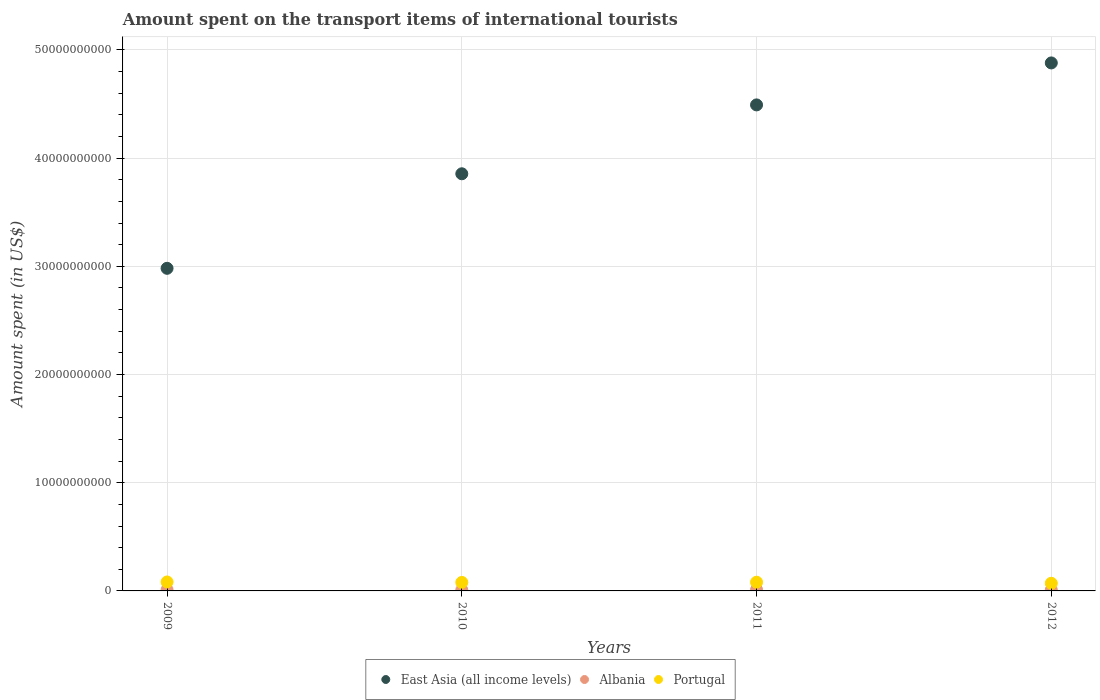How many different coloured dotlines are there?
Your answer should be very brief. 3. What is the amount spent on the transport items of international tourists in East Asia (all income levels) in 2010?
Provide a succinct answer. 3.86e+1. Across all years, what is the maximum amount spent on the transport items of international tourists in Albania?
Your response must be concise. 1.13e+08. Across all years, what is the minimum amount spent on the transport items of international tourists in Portugal?
Your answer should be compact. 7.06e+08. In which year was the amount spent on the transport items of international tourists in East Asia (all income levels) minimum?
Keep it short and to the point. 2009. What is the total amount spent on the transport items of international tourists in Portugal in the graph?
Keep it short and to the point. 3.12e+09. What is the difference between the amount spent on the transport items of international tourists in Albania in 2009 and that in 2012?
Your answer should be compact. 1.70e+07. What is the difference between the amount spent on the transport items of international tourists in Albania in 2012 and the amount spent on the transport items of international tourists in Portugal in 2010?
Keep it short and to the point. -6.96e+08. What is the average amount spent on the transport items of international tourists in Albania per year?
Provide a short and direct response. 1.00e+08. In the year 2010, what is the difference between the amount spent on the transport items of international tourists in Portugal and amount spent on the transport items of international tourists in Albania?
Ensure brevity in your answer.  6.94e+08. What is the ratio of the amount spent on the transport items of international tourists in Albania in 2010 to that in 2011?
Your response must be concise. 0.81. Is the amount spent on the transport items of international tourists in East Asia (all income levels) in 2010 less than that in 2011?
Keep it short and to the point. Yes. What is the difference between the highest and the second highest amount spent on the transport items of international tourists in East Asia (all income levels)?
Make the answer very short. 3.88e+09. What is the difference between the highest and the lowest amount spent on the transport items of international tourists in Portugal?
Offer a very short reply. 1.22e+08. Is the sum of the amount spent on the transport items of international tourists in Portugal in 2009 and 2012 greater than the maximum amount spent on the transport items of international tourists in East Asia (all income levels) across all years?
Keep it short and to the point. No. Does the amount spent on the transport items of international tourists in Albania monotonically increase over the years?
Give a very brief answer. No. Is the amount spent on the transport items of international tourists in Portugal strictly less than the amount spent on the transport items of international tourists in East Asia (all income levels) over the years?
Give a very brief answer. Yes. How many dotlines are there?
Make the answer very short. 3. How many years are there in the graph?
Provide a short and direct response. 4. Are the values on the major ticks of Y-axis written in scientific E-notation?
Your answer should be compact. No. Where does the legend appear in the graph?
Ensure brevity in your answer.  Bottom center. What is the title of the graph?
Offer a terse response. Amount spent on the transport items of international tourists. Does "South Africa" appear as one of the legend labels in the graph?
Offer a very short reply. No. What is the label or title of the Y-axis?
Your response must be concise. Amount spent (in US$). What is the Amount spent (in US$) of East Asia (all income levels) in 2009?
Your answer should be very brief. 2.98e+1. What is the Amount spent (in US$) of Albania in 2009?
Provide a short and direct response. 1.07e+08. What is the Amount spent (in US$) in Portugal in 2009?
Make the answer very short. 8.28e+08. What is the Amount spent (in US$) of East Asia (all income levels) in 2010?
Ensure brevity in your answer.  3.86e+1. What is the Amount spent (in US$) in Albania in 2010?
Offer a very short reply. 9.20e+07. What is the Amount spent (in US$) in Portugal in 2010?
Offer a very short reply. 7.86e+08. What is the Amount spent (in US$) of East Asia (all income levels) in 2011?
Give a very brief answer. 4.49e+1. What is the Amount spent (in US$) in Albania in 2011?
Offer a very short reply. 1.13e+08. What is the Amount spent (in US$) of Portugal in 2011?
Your answer should be compact. 8.05e+08. What is the Amount spent (in US$) of East Asia (all income levels) in 2012?
Ensure brevity in your answer.  4.88e+1. What is the Amount spent (in US$) in Albania in 2012?
Provide a short and direct response. 9.00e+07. What is the Amount spent (in US$) in Portugal in 2012?
Your answer should be compact. 7.06e+08. Across all years, what is the maximum Amount spent (in US$) of East Asia (all income levels)?
Your answer should be very brief. 4.88e+1. Across all years, what is the maximum Amount spent (in US$) of Albania?
Your answer should be compact. 1.13e+08. Across all years, what is the maximum Amount spent (in US$) of Portugal?
Make the answer very short. 8.28e+08. Across all years, what is the minimum Amount spent (in US$) of East Asia (all income levels)?
Offer a very short reply. 2.98e+1. Across all years, what is the minimum Amount spent (in US$) of Albania?
Ensure brevity in your answer.  9.00e+07. Across all years, what is the minimum Amount spent (in US$) of Portugal?
Keep it short and to the point. 7.06e+08. What is the total Amount spent (in US$) of East Asia (all income levels) in the graph?
Keep it short and to the point. 1.62e+11. What is the total Amount spent (in US$) in Albania in the graph?
Ensure brevity in your answer.  4.02e+08. What is the total Amount spent (in US$) in Portugal in the graph?
Provide a short and direct response. 3.12e+09. What is the difference between the Amount spent (in US$) in East Asia (all income levels) in 2009 and that in 2010?
Your response must be concise. -8.74e+09. What is the difference between the Amount spent (in US$) in Albania in 2009 and that in 2010?
Make the answer very short. 1.50e+07. What is the difference between the Amount spent (in US$) in Portugal in 2009 and that in 2010?
Make the answer very short. 4.20e+07. What is the difference between the Amount spent (in US$) of East Asia (all income levels) in 2009 and that in 2011?
Provide a succinct answer. -1.51e+1. What is the difference between the Amount spent (in US$) of Albania in 2009 and that in 2011?
Offer a terse response. -6.00e+06. What is the difference between the Amount spent (in US$) of Portugal in 2009 and that in 2011?
Provide a short and direct response. 2.30e+07. What is the difference between the Amount spent (in US$) in East Asia (all income levels) in 2009 and that in 2012?
Offer a very short reply. -1.90e+1. What is the difference between the Amount spent (in US$) of Albania in 2009 and that in 2012?
Your response must be concise. 1.70e+07. What is the difference between the Amount spent (in US$) of Portugal in 2009 and that in 2012?
Your answer should be very brief. 1.22e+08. What is the difference between the Amount spent (in US$) in East Asia (all income levels) in 2010 and that in 2011?
Give a very brief answer. -6.37e+09. What is the difference between the Amount spent (in US$) of Albania in 2010 and that in 2011?
Provide a short and direct response. -2.10e+07. What is the difference between the Amount spent (in US$) in Portugal in 2010 and that in 2011?
Make the answer very short. -1.90e+07. What is the difference between the Amount spent (in US$) of East Asia (all income levels) in 2010 and that in 2012?
Offer a terse response. -1.02e+1. What is the difference between the Amount spent (in US$) of Albania in 2010 and that in 2012?
Your answer should be compact. 2.00e+06. What is the difference between the Amount spent (in US$) in Portugal in 2010 and that in 2012?
Your answer should be compact. 8.00e+07. What is the difference between the Amount spent (in US$) of East Asia (all income levels) in 2011 and that in 2012?
Ensure brevity in your answer.  -3.88e+09. What is the difference between the Amount spent (in US$) in Albania in 2011 and that in 2012?
Keep it short and to the point. 2.30e+07. What is the difference between the Amount spent (in US$) in Portugal in 2011 and that in 2012?
Your answer should be compact. 9.90e+07. What is the difference between the Amount spent (in US$) of East Asia (all income levels) in 2009 and the Amount spent (in US$) of Albania in 2010?
Give a very brief answer. 2.97e+1. What is the difference between the Amount spent (in US$) in East Asia (all income levels) in 2009 and the Amount spent (in US$) in Portugal in 2010?
Your response must be concise. 2.90e+1. What is the difference between the Amount spent (in US$) of Albania in 2009 and the Amount spent (in US$) of Portugal in 2010?
Your answer should be very brief. -6.79e+08. What is the difference between the Amount spent (in US$) in East Asia (all income levels) in 2009 and the Amount spent (in US$) in Albania in 2011?
Offer a very short reply. 2.97e+1. What is the difference between the Amount spent (in US$) in East Asia (all income levels) in 2009 and the Amount spent (in US$) in Portugal in 2011?
Offer a terse response. 2.90e+1. What is the difference between the Amount spent (in US$) in Albania in 2009 and the Amount spent (in US$) in Portugal in 2011?
Provide a short and direct response. -6.98e+08. What is the difference between the Amount spent (in US$) of East Asia (all income levels) in 2009 and the Amount spent (in US$) of Albania in 2012?
Provide a succinct answer. 2.97e+1. What is the difference between the Amount spent (in US$) of East Asia (all income levels) in 2009 and the Amount spent (in US$) of Portugal in 2012?
Provide a succinct answer. 2.91e+1. What is the difference between the Amount spent (in US$) in Albania in 2009 and the Amount spent (in US$) in Portugal in 2012?
Give a very brief answer. -5.99e+08. What is the difference between the Amount spent (in US$) of East Asia (all income levels) in 2010 and the Amount spent (in US$) of Albania in 2011?
Keep it short and to the point. 3.84e+1. What is the difference between the Amount spent (in US$) in East Asia (all income levels) in 2010 and the Amount spent (in US$) in Portugal in 2011?
Your answer should be very brief. 3.78e+1. What is the difference between the Amount spent (in US$) in Albania in 2010 and the Amount spent (in US$) in Portugal in 2011?
Give a very brief answer. -7.13e+08. What is the difference between the Amount spent (in US$) in East Asia (all income levels) in 2010 and the Amount spent (in US$) in Albania in 2012?
Your answer should be very brief. 3.85e+1. What is the difference between the Amount spent (in US$) in East Asia (all income levels) in 2010 and the Amount spent (in US$) in Portugal in 2012?
Offer a terse response. 3.78e+1. What is the difference between the Amount spent (in US$) in Albania in 2010 and the Amount spent (in US$) in Portugal in 2012?
Your answer should be very brief. -6.14e+08. What is the difference between the Amount spent (in US$) of East Asia (all income levels) in 2011 and the Amount spent (in US$) of Albania in 2012?
Your answer should be compact. 4.48e+1. What is the difference between the Amount spent (in US$) in East Asia (all income levels) in 2011 and the Amount spent (in US$) in Portugal in 2012?
Make the answer very short. 4.42e+1. What is the difference between the Amount spent (in US$) in Albania in 2011 and the Amount spent (in US$) in Portugal in 2012?
Offer a terse response. -5.93e+08. What is the average Amount spent (in US$) of East Asia (all income levels) per year?
Your answer should be compact. 4.05e+1. What is the average Amount spent (in US$) in Albania per year?
Make the answer very short. 1.00e+08. What is the average Amount spent (in US$) of Portugal per year?
Offer a very short reply. 7.81e+08. In the year 2009, what is the difference between the Amount spent (in US$) in East Asia (all income levels) and Amount spent (in US$) in Albania?
Provide a succinct answer. 2.97e+1. In the year 2009, what is the difference between the Amount spent (in US$) in East Asia (all income levels) and Amount spent (in US$) in Portugal?
Make the answer very short. 2.90e+1. In the year 2009, what is the difference between the Amount spent (in US$) in Albania and Amount spent (in US$) in Portugal?
Make the answer very short. -7.21e+08. In the year 2010, what is the difference between the Amount spent (in US$) in East Asia (all income levels) and Amount spent (in US$) in Albania?
Ensure brevity in your answer.  3.85e+1. In the year 2010, what is the difference between the Amount spent (in US$) in East Asia (all income levels) and Amount spent (in US$) in Portugal?
Your response must be concise. 3.78e+1. In the year 2010, what is the difference between the Amount spent (in US$) of Albania and Amount spent (in US$) of Portugal?
Keep it short and to the point. -6.94e+08. In the year 2011, what is the difference between the Amount spent (in US$) of East Asia (all income levels) and Amount spent (in US$) of Albania?
Provide a short and direct response. 4.48e+1. In the year 2011, what is the difference between the Amount spent (in US$) of East Asia (all income levels) and Amount spent (in US$) of Portugal?
Keep it short and to the point. 4.41e+1. In the year 2011, what is the difference between the Amount spent (in US$) of Albania and Amount spent (in US$) of Portugal?
Your answer should be compact. -6.92e+08. In the year 2012, what is the difference between the Amount spent (in US$) in East Asia (all income levels) and Amount spent (in US$) in Albania?
Keep it short and to the point. 4.87e+1. In the year 2012, what is the difference between the Amount spent (in US$) in East Asia (all income levels) and Amount spent (in US$) in Portugal?
Offer a very short reply. 4.81e+1. In the year 2012, what is the difference between the Amount spent (in US$) of Albania and Amount spent (in US$) of Portugal?
Your answer should be very brief. -6.16e+08. What is the ratio of the Amount spent (in US$) of East Asia (all income levels) in 2009 to that in 2010?
Give a very brief answer. 0.77. What is the ratio of the Amount spent (in US$) of Albania in 2009 to that in 2010?
Ensure brevity in your answer.  1.16. What is the ratio of the Amount spent (in US$) of Portugal in 2009 to that in 2010?
Your response must be concise. 1.05. What is the ratio of the Amount spent (in US$) of East Asia (all income levels) in 2009 to that in 2011?
Provide a succinct answer. 0.66. What is the ratio of the Amount spent (in US$) of Albania in 2009 to that in 2011?
Your response must be concise. 0.95. What is the ratio of the Amount spent (in US$) in Portugal in 2009 to that in 2011?
Offer a terse response. 1.03. What is the ratio of the Amount spent (in US$) of East Asia (all income levels) in 2009 to that in 2012?
Provide a short and direct response. 0.61. What is the ratio of the Amount spent (in US$) in Albania in 2009 to that in 2012?
Offer a terse response. 1.19. What is the ratio of the Amount spent (in US$) of Portugal in 2009 to that in 2012?
Give a very brief answer. 1.17. What is the ratio of the Amount spent (in US$) in East Asia (all income levels) in 2010 to that in 2011?
Offer a terse response. 0.86. What is the ratio of the Amount spent (in US$) of Albania in 2010 to that in 2011?
Ensure brevity in your answer.  0.81. What is the ratio of the Amount spent (in US$) in Portugal in 2010 to that in 2011?
Your answer should be compact. 0.98. What is the ratio of the Amount spent (in US$) in East Asia (all income levels) in 2010 to that in 2012?
Keep it short and to the point. 0.79. What is the ratio of the Amount spent (in US$) in Albania in 2010 to that in 2012?
Make the answer very short. 1.02. What is the ratio of the Amount spent (in US$) of Portugal in 2010 to that in 2012?
Ensure brevity in your answer.  1.11. What is the ratio of the Amount spent (in US$) of East Asia (all income levels) in 2011 to that in 2012?
Your answer should be very brief. 0.92. What is the ratio of the Amount spent (in US$) in Albania in 2011 to that in 2012?
Make the answer very short. 1.26. What is the ratio of the Amount spent (in US$) in Portugal in 2011 to that in 2012?
Keep it short and to the point. 1.14. What is the difference between the highest and the second highest Amount spent (in US$) of East Asia (all income levels)?
Your answer should be very brief. 3.88e+09. What is the difference between the highest and the second highest Amount spent (in US$) in Portugal?
Ensure brevity in your answer.  2.30e+07. What is the difference between the highest and the lowest Amount spent (in US$) of East Asia (all income levels)?
Offer a terse response. 1.90e+1. What is the difference between the highest and the lowest Amount spent (in US$) of Albania?
Provide a succinct answer. 2.30e+07. What is the difference between the highest and the lowest Amount spent (in US$) of Portugal?
Keep it short and to the point. 1.22e+08. 